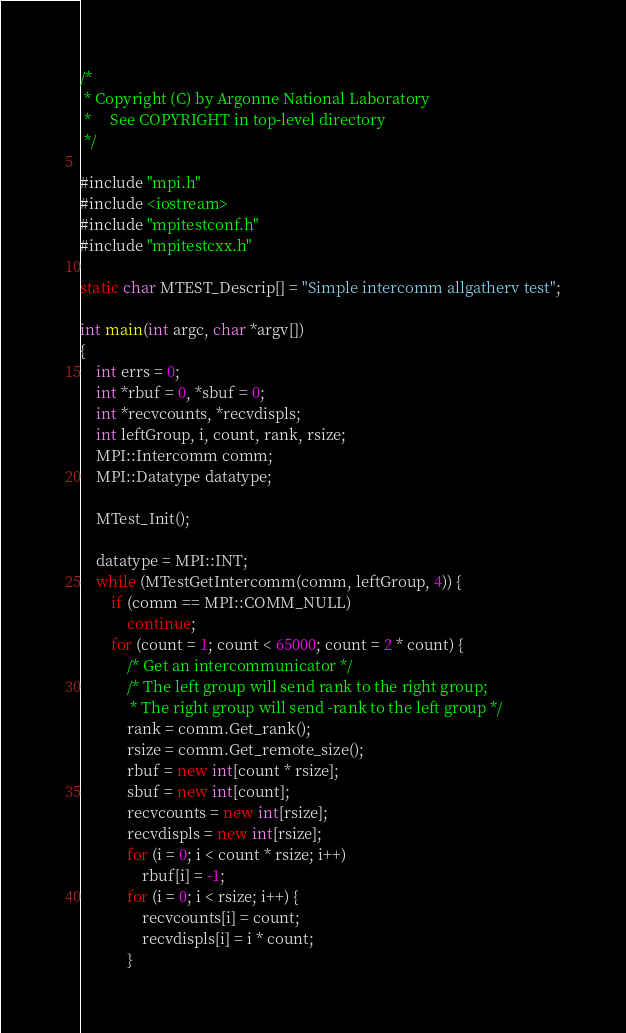Convert code to text. <code><loc_0><loc_0><loc_500><loc_500><_C++_>/*
 * Copyright (C) by Argonne National Laboratory
 *     See COPYRIGHT in top-level directory
 */

#include "mpi.h"
#include <iostream>
#include "mpitestconf.h"
#include "mpitestcxx.h"

static char MTEST_Descrip[] = "Simple intercomm allgatherv test";

int main(int argc, char *argv[])
{
    int errs = 0;
    int *rbuf = 0, *sbuf = 0;
    int *recvcounts, *recvdispls;
    int leftGroup, i, count, rank, rsize;
    MPI::Intercomm comm;
    MPI::Datatype datatype;

    MTest_Init();

    datatype = MPI::INT;
    while (MTestGetIntercomm(comm, leftGroup, 4)) {
        if (comm == MPI::COMM_NULL)
            continue;
        for (count = 1; count < 65000; count = 2 * count) {
            /* Get an intercommunicator */
            /* The left group will send rank to the right group;
             * The right group will send -rank to the left group */
            rank = comm.Get_rank();
            rsize = comm.Get_remote_size();
            rbuf = new int[count * rsize];
            sbuf = new int[count];
            recvcounts = new int[rsize];
            recvdispls = new int[rsize];
            for (i = 0; i < count * rsize; i++)
                rbuf[i] = -1;
            for (i = 0; i < rsize; i++) {
                recvcounts[i] = count;
                recvdispls[i] = i * count;
            }</code> 